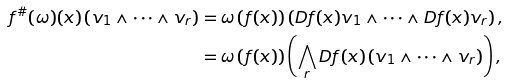Convert formula to latex. <formula><loc_0><loc_0><loc_500><loc_500>f ^ { \# } ( \omega ) ( x ) \left ( v _ { 1 } \wedge \dots \wedge v _ { r } \right ) & = \omega \left ( f ( x ) \right ) \left ( D f ( x ) v _ { 1 } \wedge \dots \wedge D f ( x ) v _ { r } \right ) , \\ & = \omega \left ( f ( x ) \right ) \left ( \bigwedge _ { r } D f ( x ) \left ( v _ { 1 } \wedge \dots \wedge v _ { r } \right ) \right ) ,</formula> 